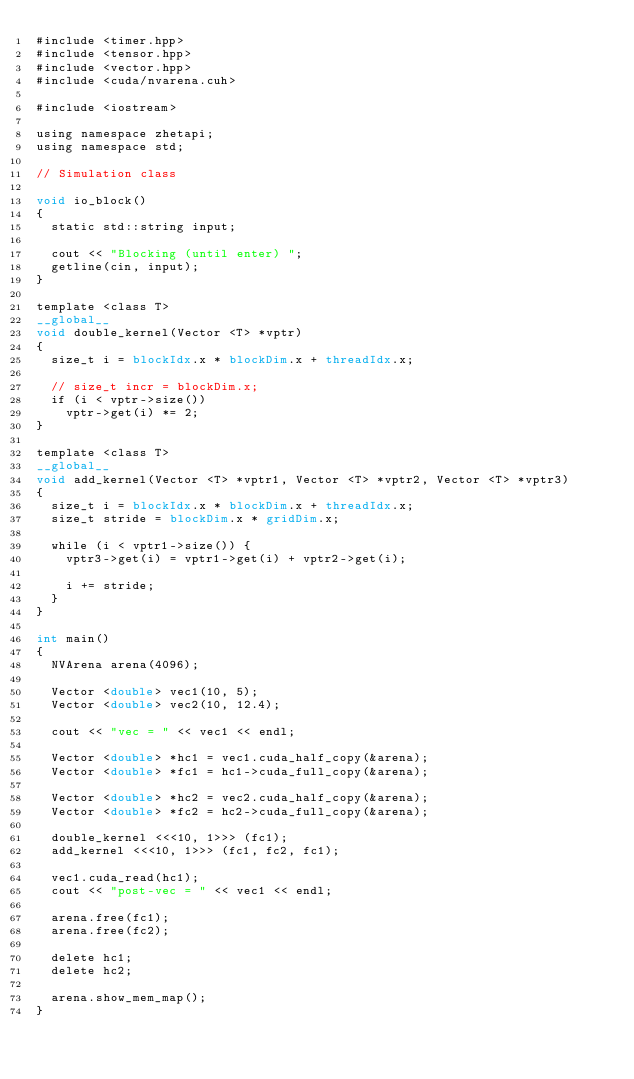Convert code to text. <code><loc_0><loc_0><loc_500><loc_500><_Cuda_>#include <timer.hpp>
#include <tensor.hpp>
#include <vector.hpp>
#include <cuda/nvarena.cuh>

#include <iostream>

using namespace zhetapi;
using namespace std;

// Simulation class

void io_block()
{
	static std::string input;

	cout << "Blocking (until enter) ";
	getline(cin, input);
}

template <class T>
__global__
void double_kernel(Vector <T> *vptr)
{
	size_t i = blockIdx.x * blockDim.x + threadIdx.x;

	// size_t incr = blockDim.x;
	if (i < vptr->size())
		vptr->get(i) *= 2;
}

template <class T>
__global__
void add_kernel(Vector <T> *vptr1, Vector <T> *vptr2, Vector <T> *vptr3)
{
	size_t i = blockIdx.x * blockDim.x + threadIdx.x;
	size_t stride = blockDim.x * gridDim.x;

	while (i < vptr1->size()) {
		vptr3->get(i) = vptr1->get(i) + vptr2->get(i);

		i += stride;
	}
}

int main()
{
	NVArena arena(4096);

	Vector <double> vec1(10, 5);
	Vector <double> vec2(10, 12.4);

	cout << "vec = " << vec1 << endl;

	Vector <double> *hc1 = vec1.cuda_half_copy(&arena);
	Vector <double> *fc1 = hc1->cuda_full_copy(&arena);

	Vector <double> *hc2 = vec2.cuda_half_copy(&arena);
	Vector <double> *fc2 = hc2->cuda_full_copy(&arena);

	double_kernel <<<10, 1>>> (fc1);
	add_kernel <<<10, 1>>> (fc1, fc2, fc1);

	vec1.cuda_read(hc1);
	cout << "post-vec = " << vec1 << endl;

	arena.free(fc1);
	arena.free(fc2);

	delete hc1;
	delete hc2;

	arena.show_mem_map();
}
</code> 